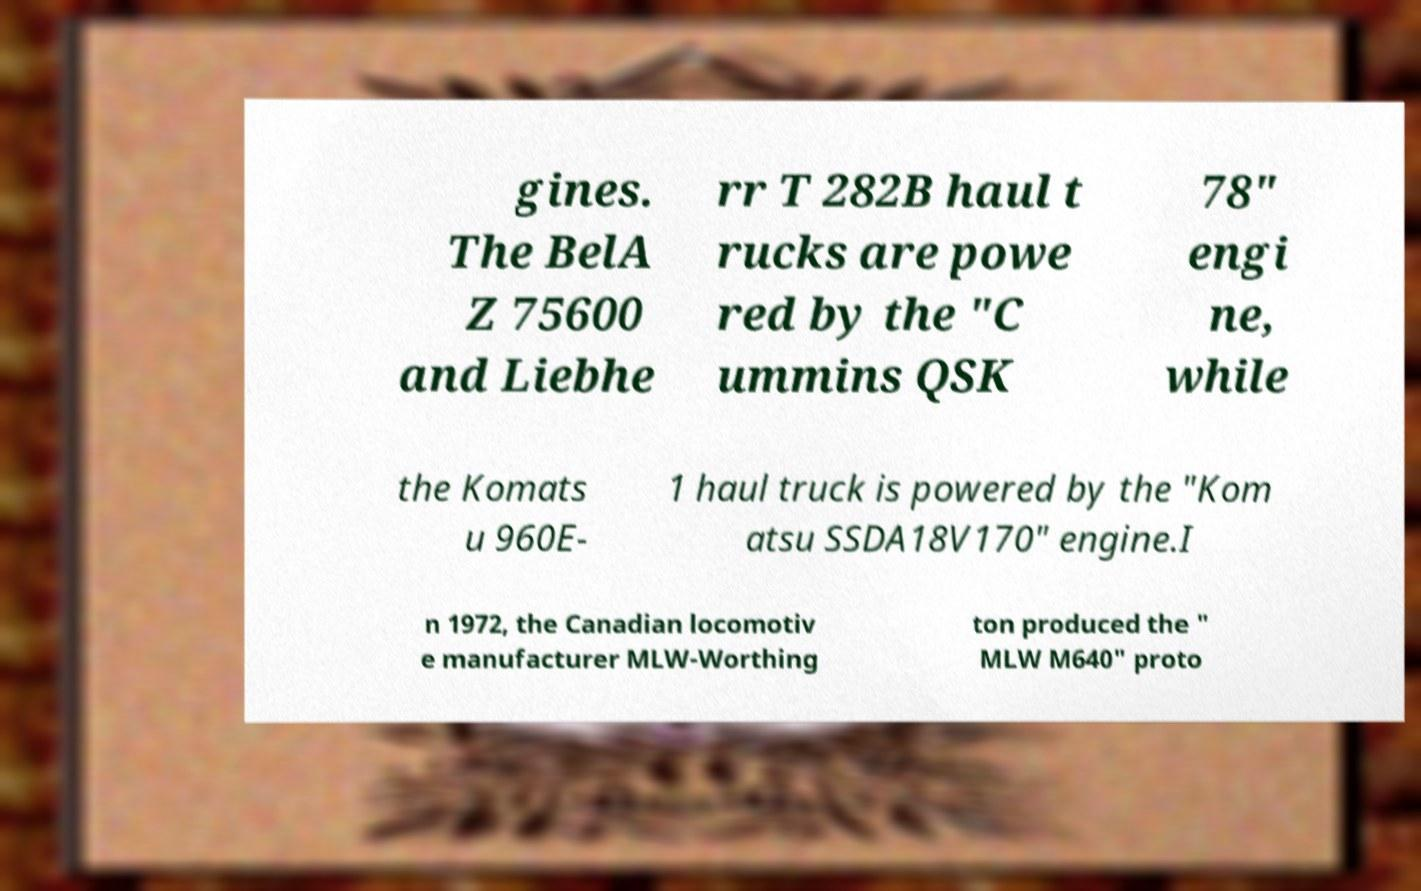Please read and relay the text visible in this image. What does it say? gines. The BelA Z 75600 and Liebhe rr T 282B haul t rucks are powe red by the "C ummins QSK 78" engi ne, while the Komats u 960E- 1 haul truck is powered by the "Kom atsu SSDA18V170" engine.I n 1972, the Canadian locomotiv e manufacturer MLW-Worthing ton produced the " MLW M640" proto 